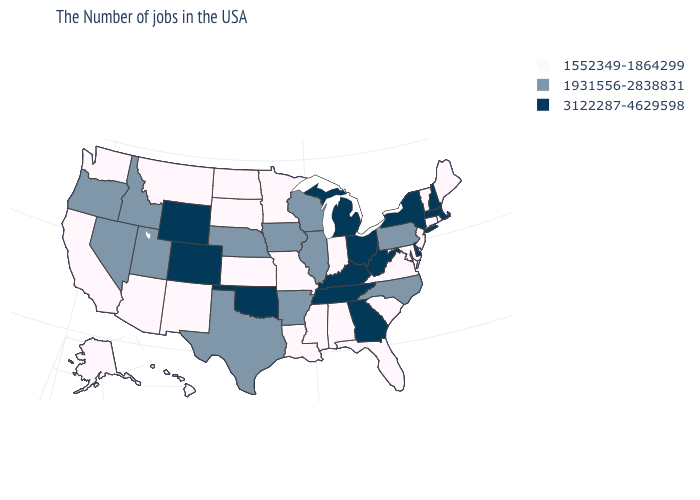Name the states that have a value in the range 3122287-4629598?
Keep it brief. Massachusetts, New Hampshire, New York, Delaware, West Virginia, Ohio, Georgia, Michigan, Kentucky, Tennessee, Oklahoma, Wyoming, Colorado. Is the legend a continuous bar?
Answer briefly. No. How many symbols are there in the legend?
Give a very brief answer. 3. Among the states that border Utah , does Colorado have the highest value?
Answer briefly. Yes. What is the value of Hawaii?
Short answer required. 1552349-1864299. Name the states that have a value in the range 1931556-2838831?
Answer briefly. Pennsylvania, North Carolina, Wisconsin, Illinois, Arkansas, Iowa, Nebraska, Texas, Utah, Idaho, Nevada, Oregon. What is the value of Connecticut?
Keep it brief. 1552349-1864299. What is the highest value in states that border Iowa?
Answer briefly. 1931556-2838831. What is the value of Delaware?
Give a very brief answer. 3122287-4629598. How many symbols are there in the legend?
Quick response, please. 3. Which states hav the highest value in the South?
Give a very brief answer. Delaware, West Virginia, Georgia, Kentucky, Tennessee, Oklahoma. Name the states that have a value in the range 1931556-2838831?
Give a very brief answer. Pennsylvania, North Carolina, Wisconsin, Illinois, Arkansas, Iowa, Nebraska, Texas, Utah, Idaho, Nevada, Oregon. Which states have the highest value in the USA?
Short answer required. Massachusetts, New Hampshire, New York, Delaware, West Virginia, Ohio, Georgia, Michigan, Kentucky, Tennessee, Oklahoma, Wyoming, Colorado. Among the states that border Kansas , does Oklahoma have the highest value?
Write a very short answer. Yes. What is the highest value in the MidWest ?
Answer briefly. 3122287-4629598. 